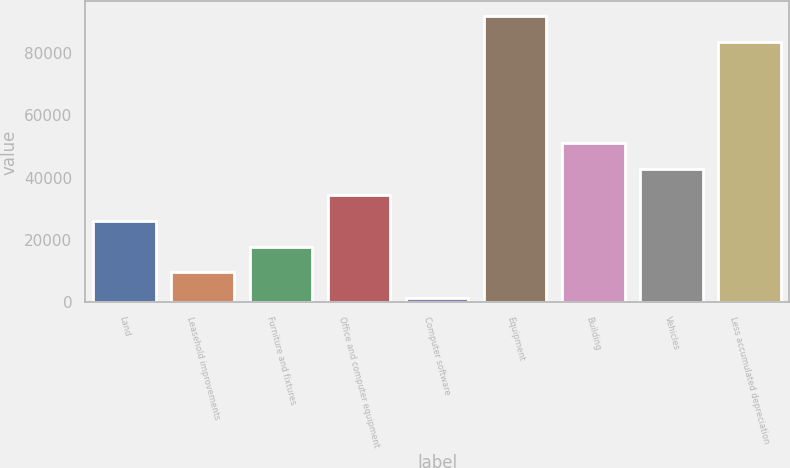<chart> <loc_0><loc_0><loc_500><loc_500><bar_chart><fcel>Land<fcel>Leasehold improvements<fcel>Furniture and fixtures<fcel>Office and computer equipment<fcel>Computer software<fcel>Equipment<fcel>Building<fcel>Vehicles<fcel>Less accumulated depreciation<nl><fcel>26200.8<fcel>9611.6<fcel>17906.2<fcel>34495.4<fcel>1317<fcel>91873.6<fcel>51084.6<fcel>42790<fcel>83579<nl></chart> 